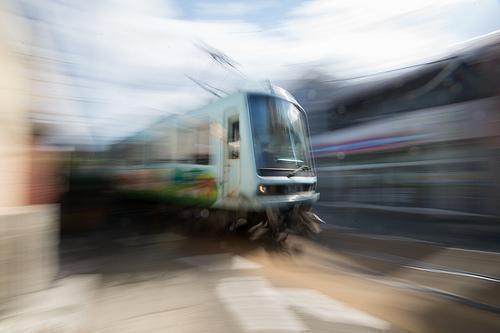How many trains are pictured?
Give a very brief answer. 1. 